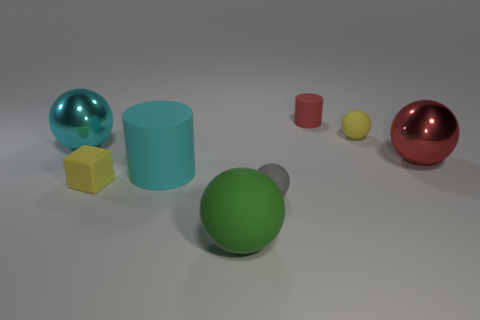Subtract all big green spheres. How many spheres are left? 4 Add 2 big blue cubes. How many objects exist? 10 Subtract all green balls. How many balls are left? 4 Subtract 1 cubes. How many cubes are left? 0 Subtract all blue balls. Subtract all brown cylinders. How many balls are left? 5 Subtract all blue spheres. How many red cylinders are left? 1 Subtract all red balls. Subtract all gray rubber balls. How many objects are left? 6 Add 1 matte spheres. How many matte spheres are left? 4 Add 6 blue balls. How many blue balls exist? 6 Subtract 0 purple balls. How many objects are left? 8 